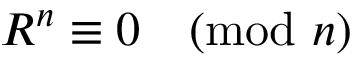<formula> <loc_0><loc_0><loc_500><loc_500>R ^ { n } \equiv 0 { \pmod { n } }</formula> 